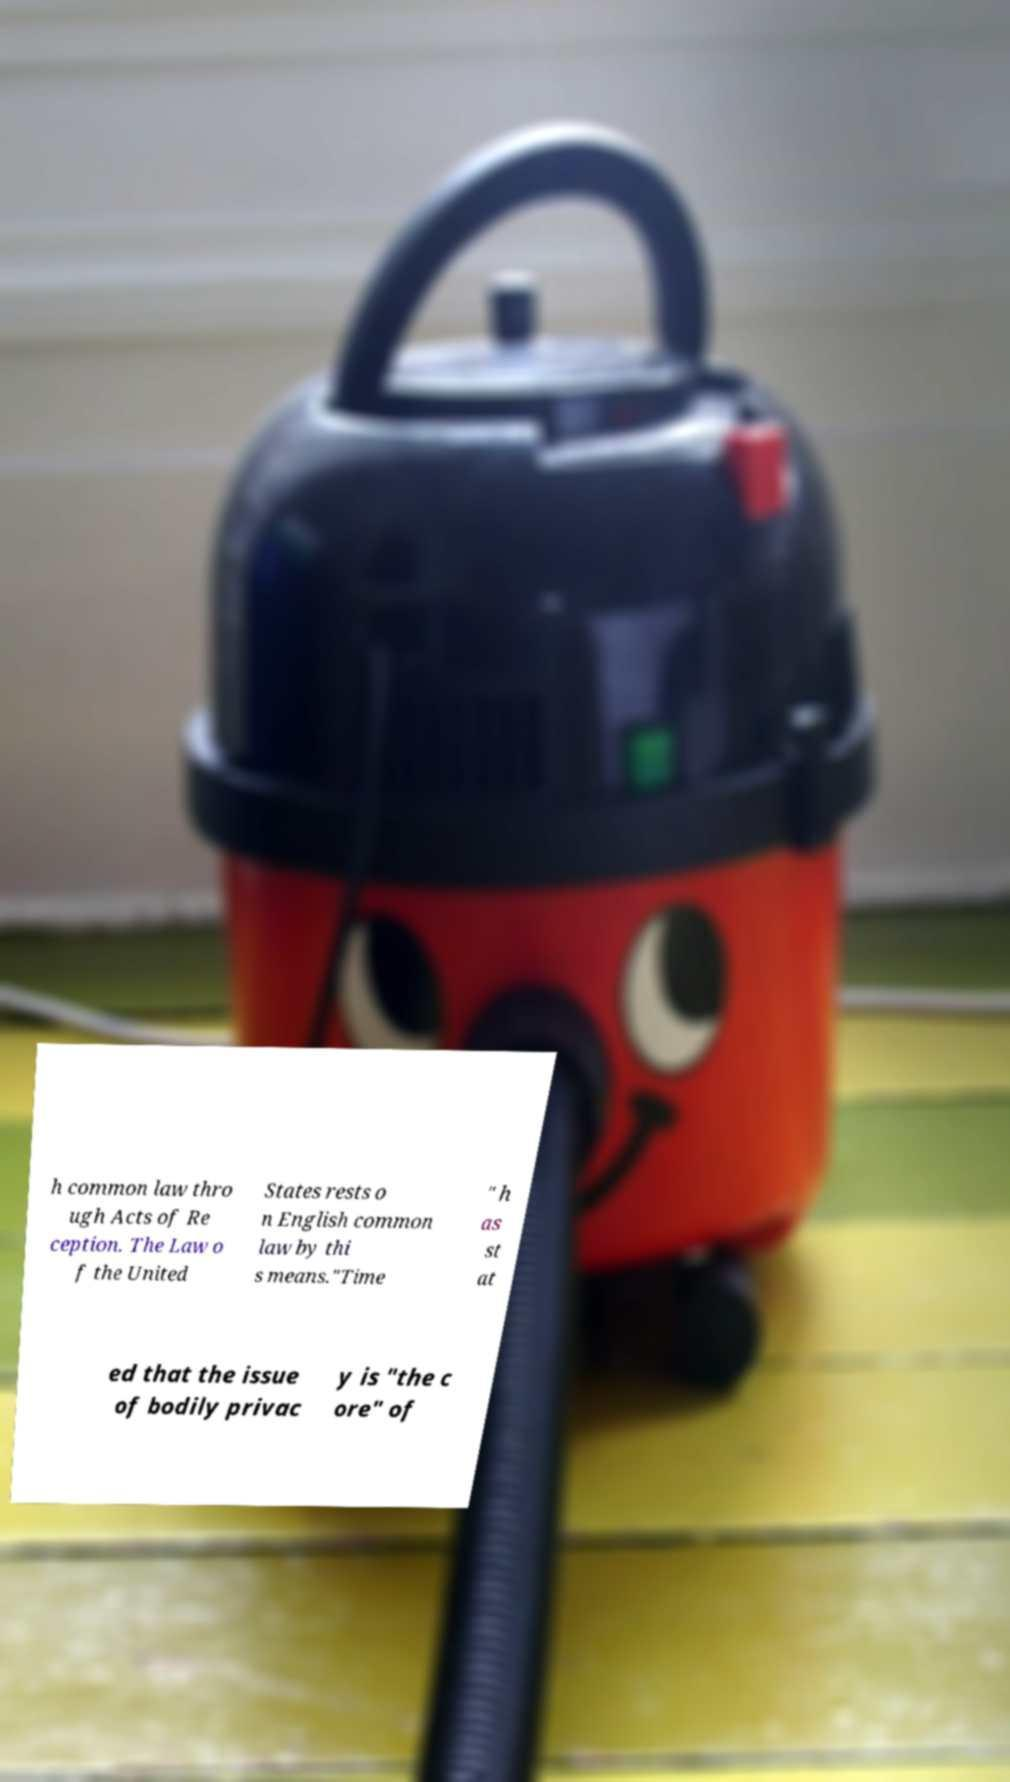Please read and relay the text visible in this image. What does it say? h common law thro ugh Acts of Re ception. The Law o f the United States rests o n English common law by thi s means."Time " h as st at ed that the issue of bodily privac y is "the c ore" of 